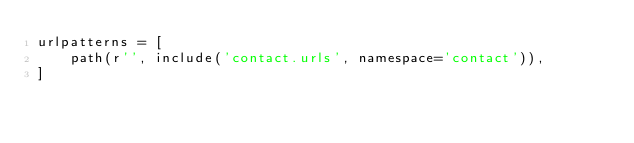Convert code to text. <code><loc_0><loc_0><loc_500><loc_500><_Python_>urlpatterns = [
    path(r'', include('contact.urls', namespace='contact')),
]
</code> 